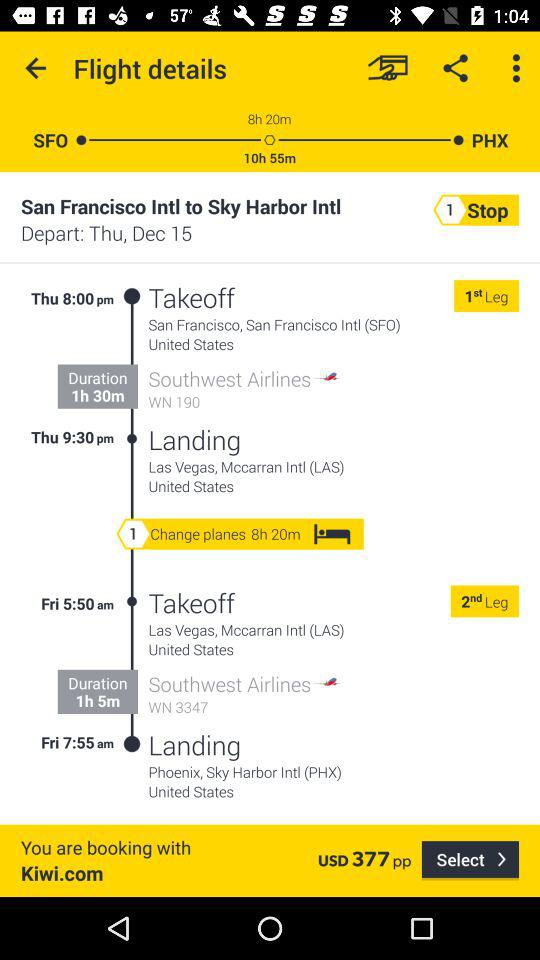How many hours is the total flight time?
Answer the question using a single word or phrase. 10h 55m 